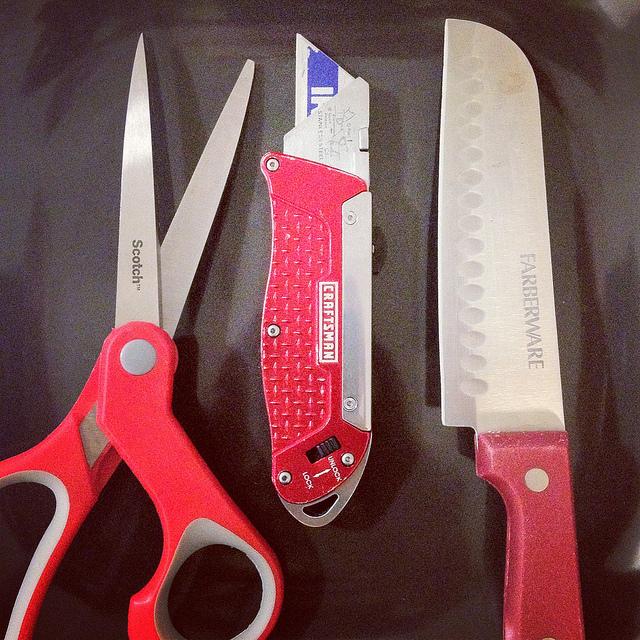What color are the scissors?
Quick response, please. Red. What is the thing on the right?
Keep it brief. Knife. Are there scissors in this picture?
Quick response, please. Yes. 